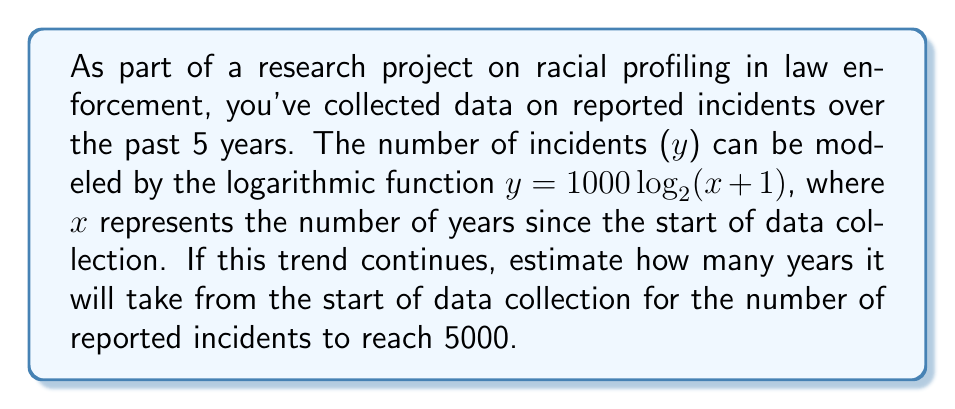Solve this math problem. To solve this problem, we need to use the given logarithmic function and solve for x when y = 5000. Let's approach this step-by-step:

1) The given function is $y = 1000 \log_2(x + 1)$

2) We want to find x when y = 5000, so we substitute this:

   $5000 = 1000 \log_2(x + 1)$

3) Divide both sides by 1000:

   $5 = \log_2(x + 1)$

4) To solve for x, we need to apply the inverse function (exponential) to both sides:

   $2^5 = x + 1$

5) Simplify the left side:

   $32 = x + 1$

6) Subtract 1 from both sides:

   $31 = x$

Therefore, it will take approximately 31 years from the start of data collection for the number of reported incidents to reach 5000, assuming the logarithmic trend continues.
Answer: 31 years 